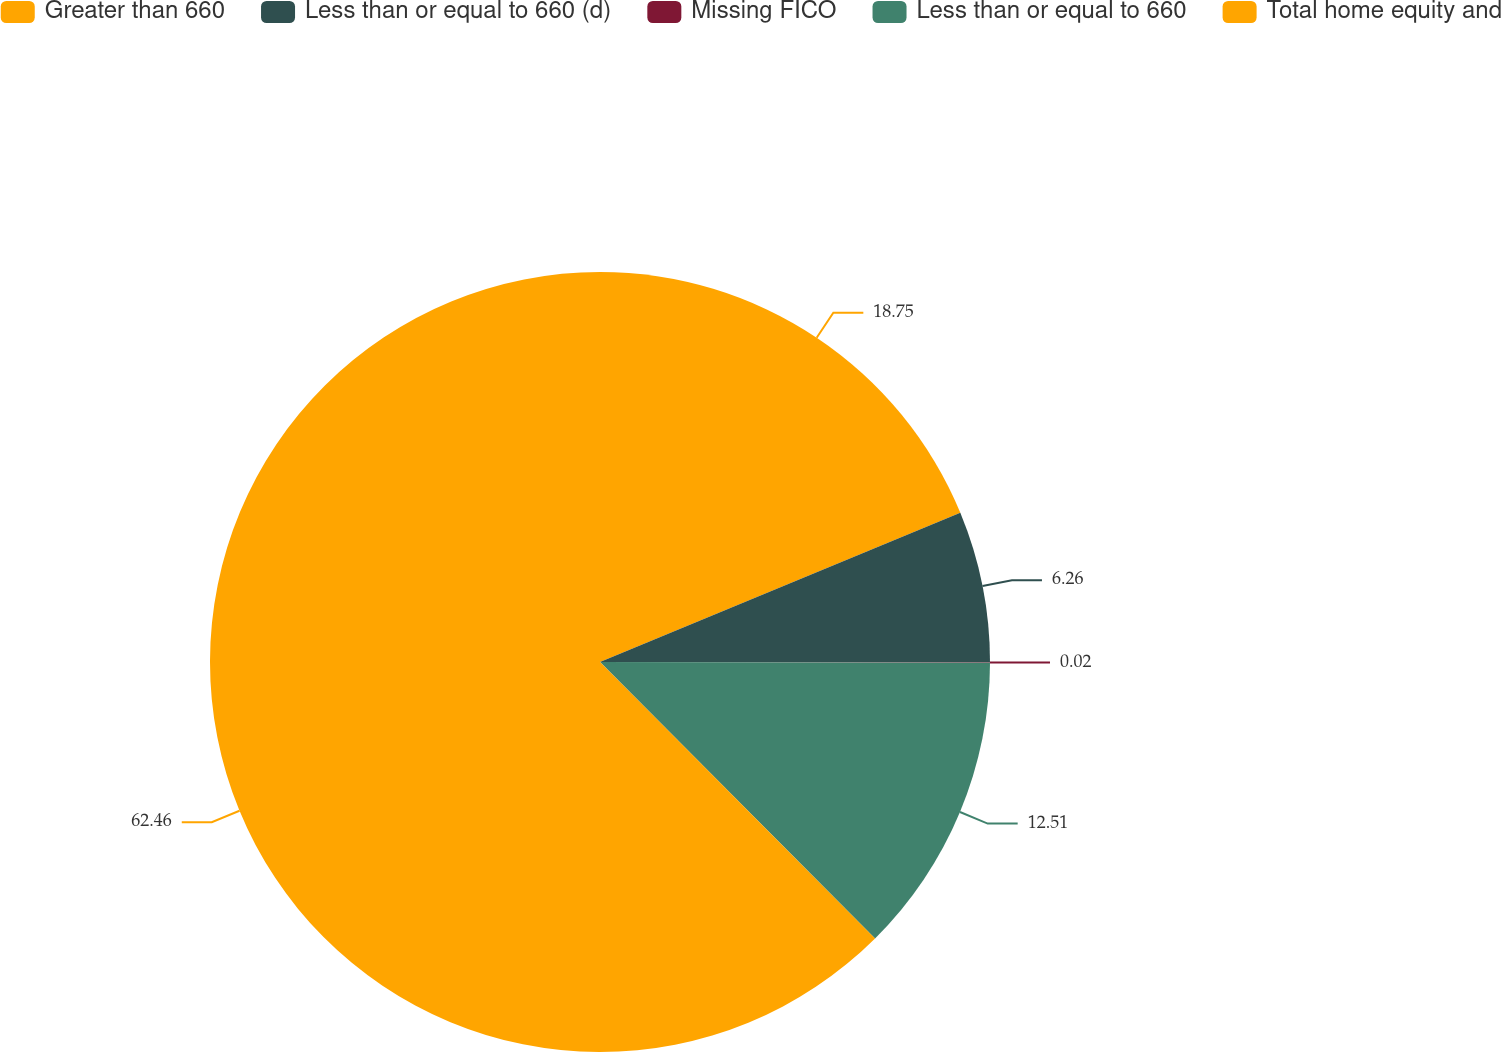<chart> <loc_0><loc_0><loc_500><loc_500><pie_chart><fcel>Greater than 660<fcel>Less than or equal to 660 (d)<fcel>Missing FICO<fcel>Less than or equal to 660<fcel>Total home equity and<nl><fcel>18.75%<fcel>6.26%<fcel>0.02%<fcel>12.51%<fcel>62.46%<nl></chart> 